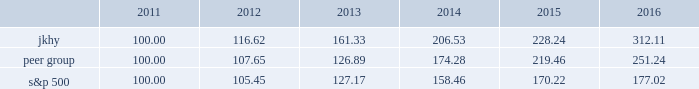22 2016 annual report performance graph the following chart presents a comparison for the five-year period ended june 30 , 2016 , of the market performance of the company 2019s common stock with the s&p 500 index and an index of peer companies selected by the company : comparison of 5 year cumulative total return among jack henry & associates , inc. , the s&p 500 index , and a peer group the following information depicts a line graph with the following values: .
This comparison assumes $ 100 was invested on june 30 , 2011 , and assumes reinvestments of dividends .
Total returns are calculated according to market capitalization of peer group members at the beginning of each period .
Peer companies selected are in the business of providing specialized computer software , hardware and related services to financial institutions and other businesses .
Companies in the peer group are aci worldwide , inc. , bottomline technology , inc. , broadridge financial solutions , cardtronics , inc. , convergys corp. , corelogic , inc. , dst systems , inc. , euronet worldwide , inc. , fair isaac corp. , fidelity national information services , inc. , fiserv , inc. , global payments , inc. , moneygram international , inc. , ss&c technologies holdings , inc. , total systems services , inc. , tyler technologies , inc. , verifone systems , inc. , and wex , inc. .
Heartland payment systems , inc .
Was removed from the peer group as it merged with global payments , inc .
In april 2016. .
What was the 2012 total return on the s&p 500? 
Computations: (105.45 - 100.00)
Answer: 5.45. 22 2016 annual report performance graph the following chart presents a comparison for the five-year period ended june 30 , 2016 , of the market performance of the company 2019s common stock with the s&p 500 index and an index of peer companies selected by the company : comparison of 5 year cumulative total return among jack henry & associates , inc. , the s&p 500 index , and a peer group the following information depicts a line graph with the following values: .
This comparison assumes $ 100 was invested on june 30 , 2011 , and assumes reinvestments of dividends .
Total returns are calculated according to market capitalization of peer group members at the beginning of each period .
Peer companies selected are in the business of providing specialized computer software , hardware and related services to financial institutions and other businesses .
Companies in the peer group are aci worldwide , inc. , bottomline technology , inc. , broadridge financial solutions , cardtronics , inc. , convergys corp. , corelogic , inc. , dst systems , inc. , euronet worldwide , inc. , fair isaac corp. , fidelity national information services , inc. , fiserv , inc. , global payments , inc. , moneygram international , inc. , ss&c technologies holdings , inc. , total systems services , inc. , tyler technologies , inc. , verifone systems , inc. , and wex , inc. .
Heartland payment systems , inc .
Was removed from the peer group as it merged with global payments , inc .
In april 2016. .
What was the percentage performance growth in the 5 year cumulative total return of peer group from 2014 to 2016? 
Computations: ((219.46 - 174.28) / 174.28)
Answer: 0.25924. 22 2016 annual report performance graph the following chart presents a comparison for the five-year period ended june 30 , 2016 , of the market performance of the company 2019s common stock with the s&p 500 index and an index of peer companies selected by the company : comparison of 5 year cumulative total return among jack henry & associates , inc. , the s&p 500 index , and a peer group the following information depicts a line graph with the following values: .
This comparison assumes $ 100 was invested on june 30 , 2011 , and assumes reinvestments of dividends .
Total returns are calculated according to market capitalization of peer group members at the beginning of each period .
Peer companies selected are in the business of providing specialized computer software , hardware and related services to financial institutions and other businesses .
Companies in the peer group are aci worldwide , inc. , bottomline technology , inc. , broadridge financial solutions , cardtronics , inc. , convergys corp. , corelogic , inc. , dst systems , inc. , euronet worldwide , inc. , fair isaac corp. , fidelity national information services , inc. , fiserv , inc. , global payments , inc. , moneygram international , inc. , ss&c technologies holdings , inc. , total systems services , inc. , tyler technologies , inc. , verifone systems , inc. , and wex , inc. .
Heartland payment systems , inc .
Was removed from the peer group as it merged with global payments , inc .
In april 2016. .
What was the total amount of returns that jkhy , peer group and s&p 500 had made combined by june 30 , 2012? 
Rationale: the one year growth for each company added up .
Computations: ((105.45 - 100) + ((116.62 - 100) + (107.65 - 100)))
Answer: 29.72. 